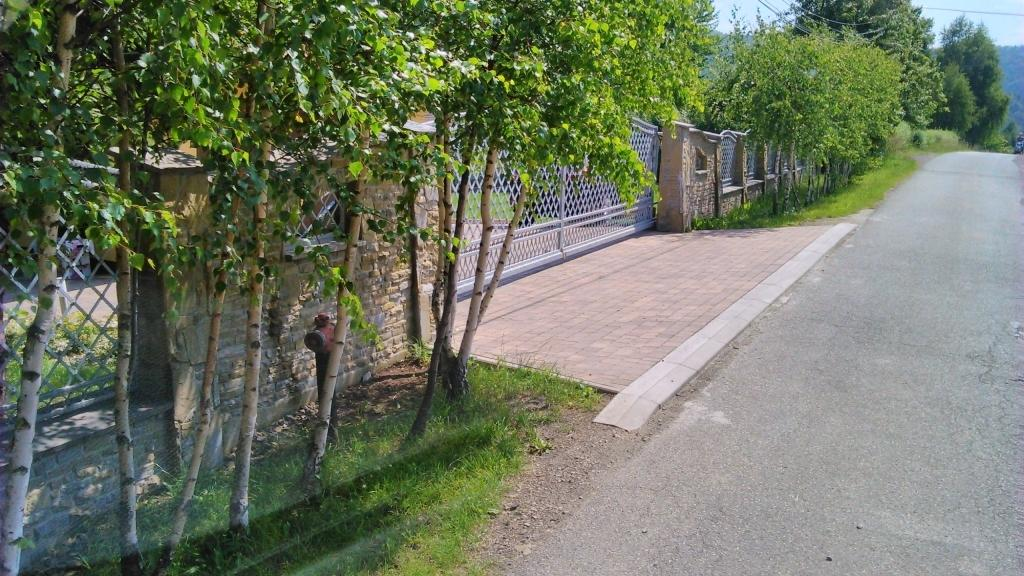What type of vegetation can be seen in the image? There is grass and trees in the image. What type of structure is present in the image? There is a fence in the image. What other object can be seen in the image? There is a fire hydrant in the image. What type of landscape feature is visible in the image? There are mountains in the image. What part of the natural environment is visible in the image? The sky is visible in the image. Based on the presence of the sky and the absence of artificial lighting, when do you think the image was taken? The image was likely taken during the day. What type of nail is being used to hold the nut in place on the coach in the image? There is no coach, nail, or nut present in the image. 